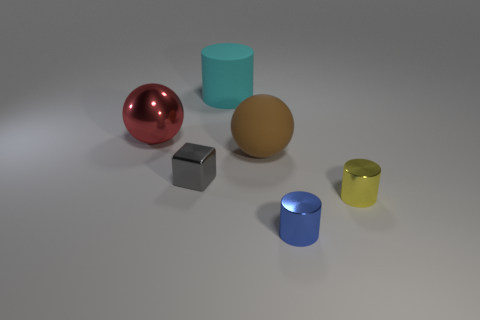Add 1 small purple cubes. How many objects exist? 7 Subtract all balls. How many objects are left? 4 Subtract 0 purple blocks. How many objects are left? 6 Subtract all blocks. Subtract all big matte cylinders. How many objects are left? 4 Add 3 tiny gray objects. How many tiny gray objects are left? 4 Add 4 small green things. How many small green things exist? 4 